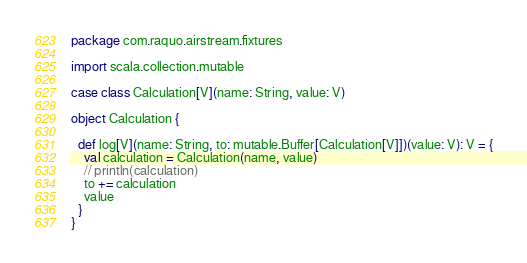<code> <loc_0><loc_0><loc_500><loc_500><_Scala_>package com.raquo.airstream.fixtures

import scala.collection.mutable

case class Calculation[V](name: String, value: V)

object Calculation {

  def log[V](name: String, to: mutable.Buffer[Calculation[V]])(value: V): V = {
    val calculation = Calculation(name, value)
    // println(calculation)
    to += calculation
    value
  }
}
</code> 